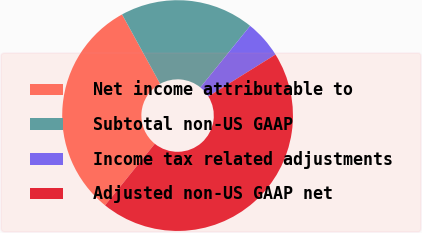Convert chart. <chart><loc_0><loc_0><loc_500><loc_500><pie_chart><fcel>Net income attributable to<fcel>Subtotal non-US GAAP<fcel>Income tax related adjustments<fcel>Adjusted non-US GAAP net<nl><fcel>31.19%<fcel>18.81%<fcel>5.31%<fcel>44.69%<nl></chart> 